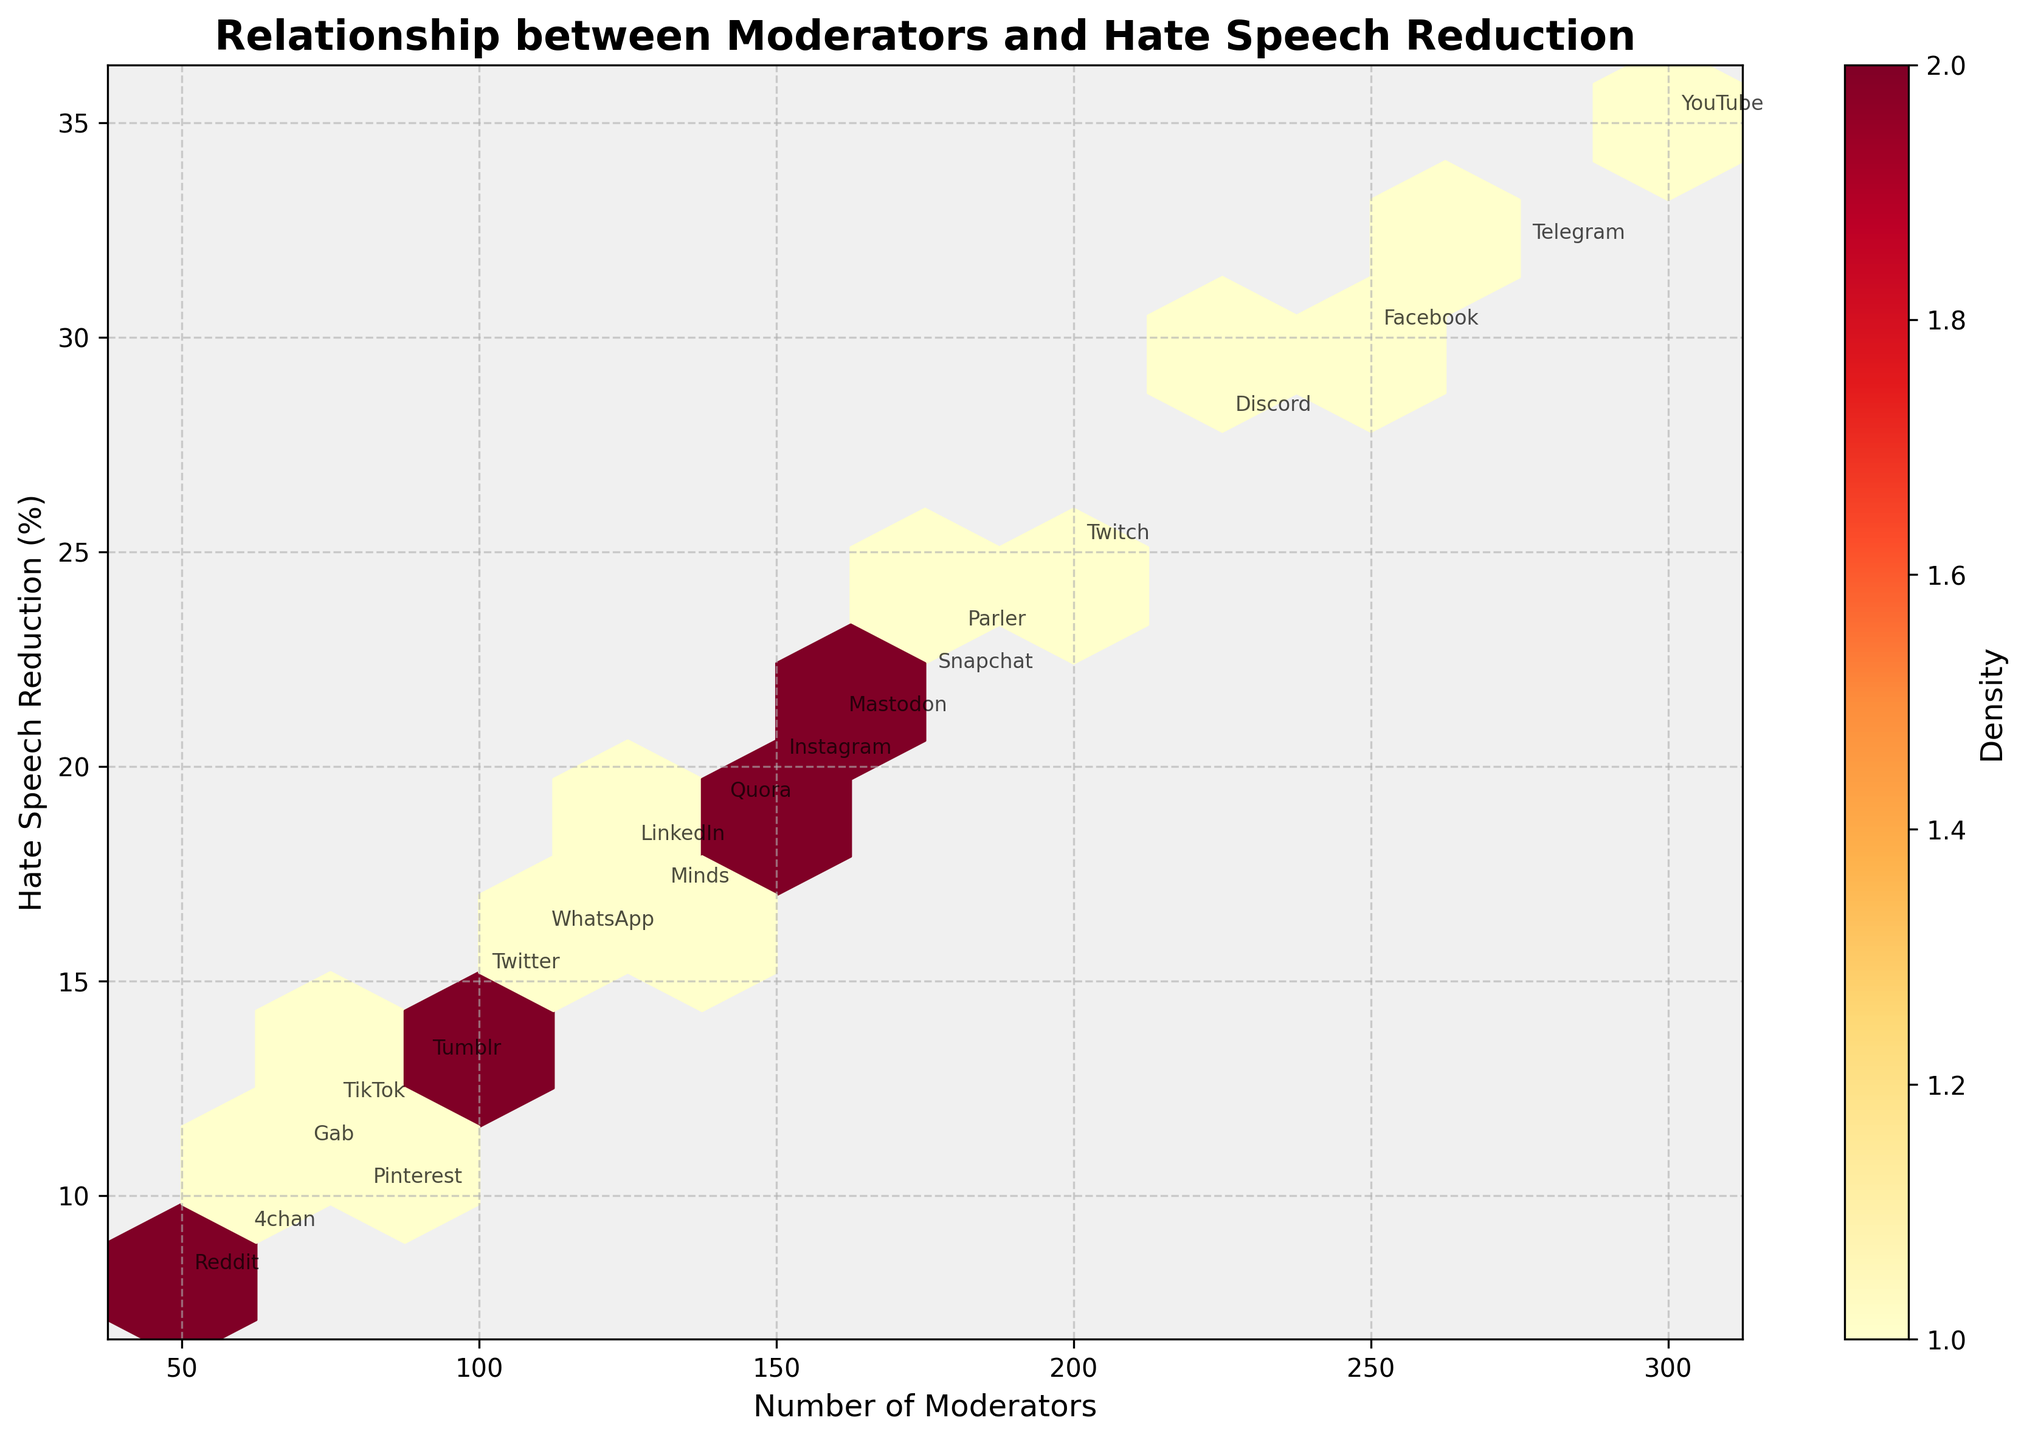What is the title of the plot? The title is usually found at the top of the plot. It gives an overview of what the plot is about.
Answer: Relationship between Moderators and Hate Speech Reduction How many platforms are represented in the plot? Count the number of different platforms mentioned in the annotations on the plot.
Answer: 20 What colors are used in the plot? Identify the different colors that appear in the hexbin plot and its components such as hexagons, axes, and annotations.
Answer: Yellow to Red shades Which platform has the highest number of moderators? Look for the platform annotation closest to the highest x-axis value.
Answer: YouTube Which platform has the lowest hate speech reduction? Identify the platform annotation closest to the lowest y-axis value.
Answer: Reddit What is the approximate density in areas with the largest number of moderators? The color density increases to a darker shade in areas with more data points. Identify the color and refer to the color bar for its meaning.
Answer: High What is the range of hate speech reduction values shown in the plot? Identify the minimum and maximum y-axis values to find the range of hate speech reduction percentages.
Answer: 8% to 35% Which platform appears closest to the middle hexagon in terms of density? Determine the platform annotation nearest to the central hexagon, considering both x and y axes.
Answer: Instagram Is there a noticeable trend between the number of moderators and the reduction in hate speech? Observe the general direction of the hexagon concentration from left to right. This will show whether there's a positive, negative or no significant correlation.
Answer: Positive trend What is the relationship between the number of moderators and the hate speech reduction for Twitch? Look at the x and y values of the platform annotation 'Twitch' and understand its position among other data points.
Answer: 200 Moderators, 25% Reduction 